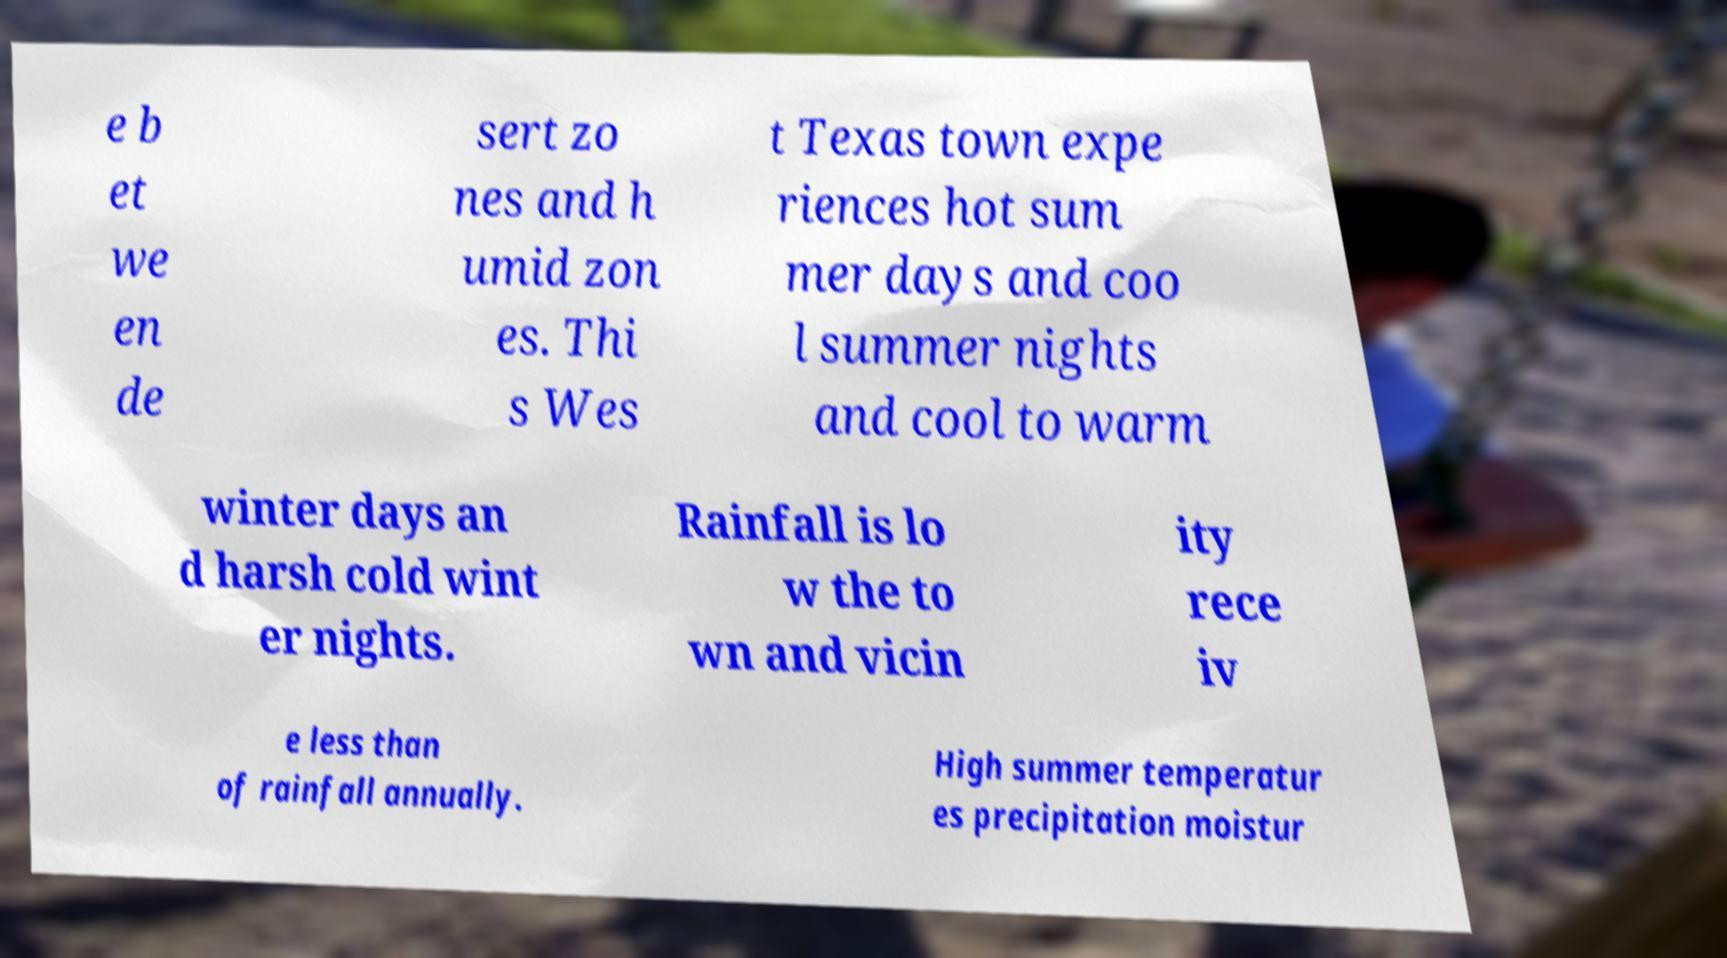Please identify and transcribe the text found in this image. e b et we en de sert zo nes and h umid zon es. Thi s Wes t Texas town expe riences hot sum mer days and coo l summer nights and cool to warm winter days an d harsh cold wint er nights. Rainfall is lo w the to wn and vicin ity rece iv e less than of rainfall annually. High summer temperatur es precipitation moistur 